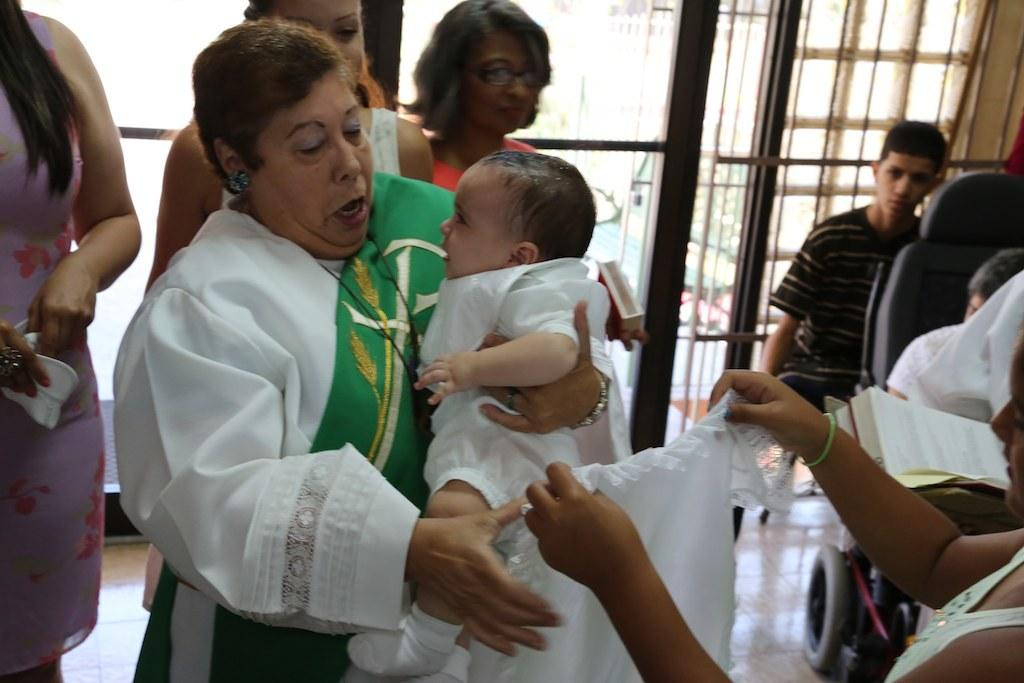What is the main subject of the image? The main subject of the image is a group of people. Can you describe the person on the right side of the image? There is a person sitting in a wheelchair on the right side of the image. What type of material is visible in the image? There are metal rods visible in the image. Is there a bear visible in the image? No, there is no bear present in the image. Is it raining in the image? The image does not provide any information about the weather, so we cannot determine if it is raining or not. 